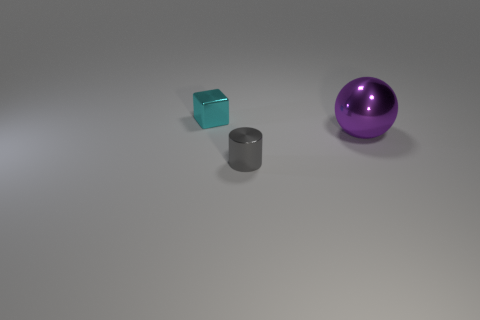The small metallic object in front of the small metal thing that is left of the small shiny object in front of the small cyan thing is what color?
Make the answer very short. Gray. Is there anything else that has the same color as the large thing?
Make the answer very short. No. Do the shiny ball and the cyan cube have the same size?
Provide a short and direct response. No. What number of things are either things right of the metallic cube or small objects left of the tiny gray metallic cylinder?
Make the answer very short. 3. The thing that is to the right of the thing that is in front of the purple shiny sphere is made of what material?
Provide a short and direct response. Metal. How many other things are made of the same material as the small cyan object?
Keep it short and to the point. 2. Is the large metal object the same shape as the cyan shiny thing?
Make the answer very short. No. What size is the gray cylinder on the left side of the purple metallic ball?
Your answer should be very brief. Small. Do the cyan cube and the metallic object that is in front of the big purple metallic thing have the same size?
Your response must be concise. Yes. Is the number of large purple objects that are behind the large purple shiny sphere less than the number of big purple blocks?
Provide a succinct answer. No. 